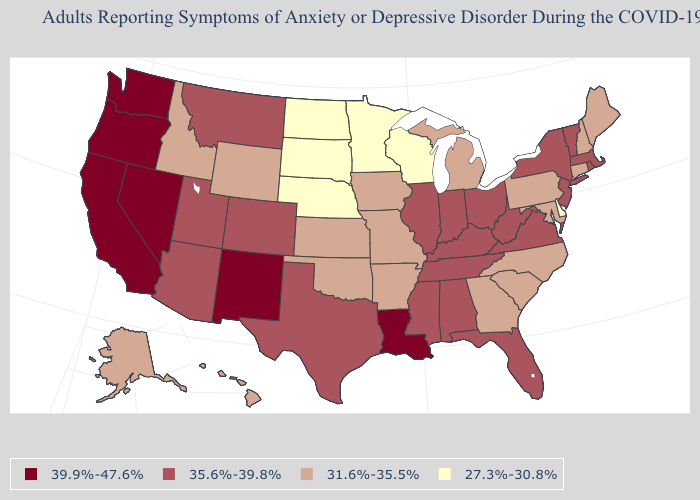Which states have the lowest value in the USA?
Quick response, please. Delaware, Minnesota, Nebraska, North Dakota, South Dakota, Wisconsin. Name the states that have a value in the range 35.6%-39.8%?
Concise answer only. Alabama, Arizona, Colorado, Florida, Illinois, Indiana, Kentucky, Massachusetts, Mississippi, Montana, New Jersey, New York, Ohio, Rhode Island, Tennessee, Texas, Utah, Vermont, Virginia, West Virginia. Does Alaska have the lowest value in the West?
Concise answer only. Yes. Name the states that have a value in the range 39.9%-47.6%?
Short answer required. California, Louisiana, Nevada, New Mexico, Oregon, Washington. Is the legend a continuous bar?
Be succinct. No. Name the states that have a value in the range 35.6%-39.8%?
Keep it brief. Alabama, Arizona, Colorado, Florida, Illinois, Indiana, Kentucky, Massachusetts, Mississippi, Montana, New Jersey, New York, Ohio, Rhode Island, Tennessee, Texas, Utah, Vermont, Virginia, West Virginia. What is the highest value in states that border Nevada?
Keep it brief. 39.9%-47.6%. What is the highest value in states that border Illinois?
Write a very short answer. 35.6%-39.8%. Among the states that border Maine , which have the lowest value?
Write a very short answer. New Hampshire. How many symbols are there in the legend?
Answer briefly. 4. Name the states that have a value in the range 35.6%-39.8%?
Short answer required. Alabama, Arizona, Colorado, Florida, Illinois, Indiana, Kentucky, Massachusetts, Mississippi, Montana, New Jersey, New York, Ohio, Rhode Island, Tennessee, Texas, Utah, Vermont, Virginia, West Virginia. Name the states that have a value in the range 27.3%-30.8%?
Write a very short answer. Delaware, Minnesota, Nebraska, North Dakota, South Dakota, Wisconsin. Name the states that have a value in the range 27.3%-30.8%?
Be succinct. Delaware, Minnesota, Nebraska, North Dakota, South Dakota, Wisconsin. Name the states that have a value in the range 35.6%-39.8%?
Write a very short answer. Alabama, Arizona, Colorado, Florida, Illinois, Indiana, Kentucky, Massachusetts, Mississippi, Montana, New Jersey, New York, Ohio, Rhode Island, Tennessee, Texas, Utah, Vermont, Virginia, West Virginia. Name the states that have a value in the range 27.3%-30.8%?
Write a very short answer. Delaware, Minnesota, Nebraska, North Dakota, South Dakota, Wisconsin. 